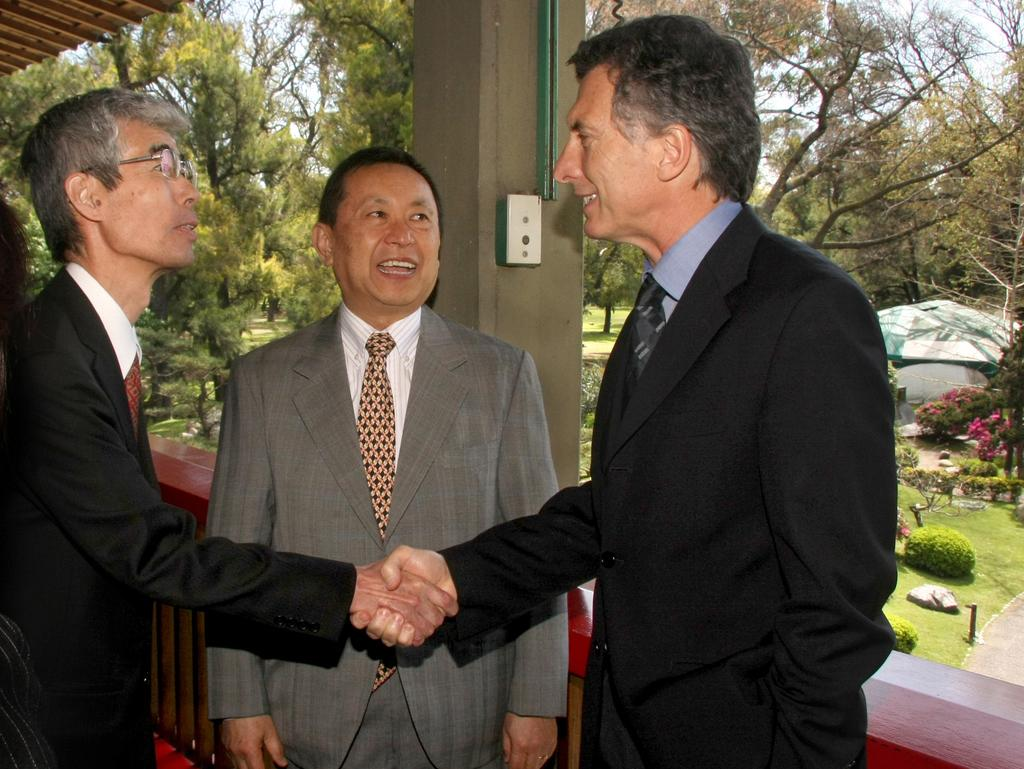What can be seen in the image? There are men standing in the image. Where are the men standing? The men are standing on the floor. What can be seen in the background of the image? There are trees, plants, grass, flowers, and the sky visible in the background of the image. How many dimes can be seen on the floor in the image? There are no dimes visible on the floor in the image. Is there a fire visible in the image? There is no fire present in the image. 